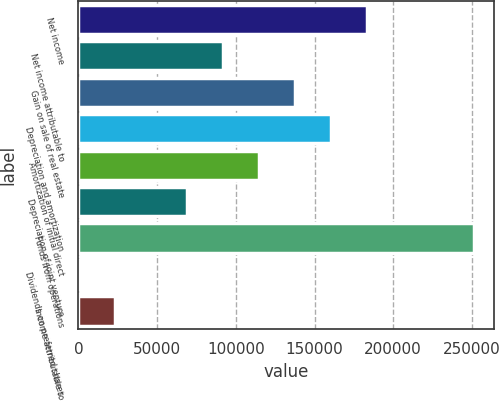Convert chart. <chart><loc_0><loc_0><loc_500><loc_500><bar_chart><fcel>Net income<fcel>Net income attributable to<fcel>Gain on sale of real estate<fcel>Depreciation and amortization<fcel>Amortization of initial direct<fcel>Depreciation of joint venture<fcel>Funds from operations<fcel>Dividends on preferred shares<fcel>Income attributable to<nl><fcel>183122<fcel>91831.4<fcel>137477<fcel>160299<fcel>114654<fcel>69008.8<fcel>251220<fcel>541<fcel>23363.6<nl></chart> 